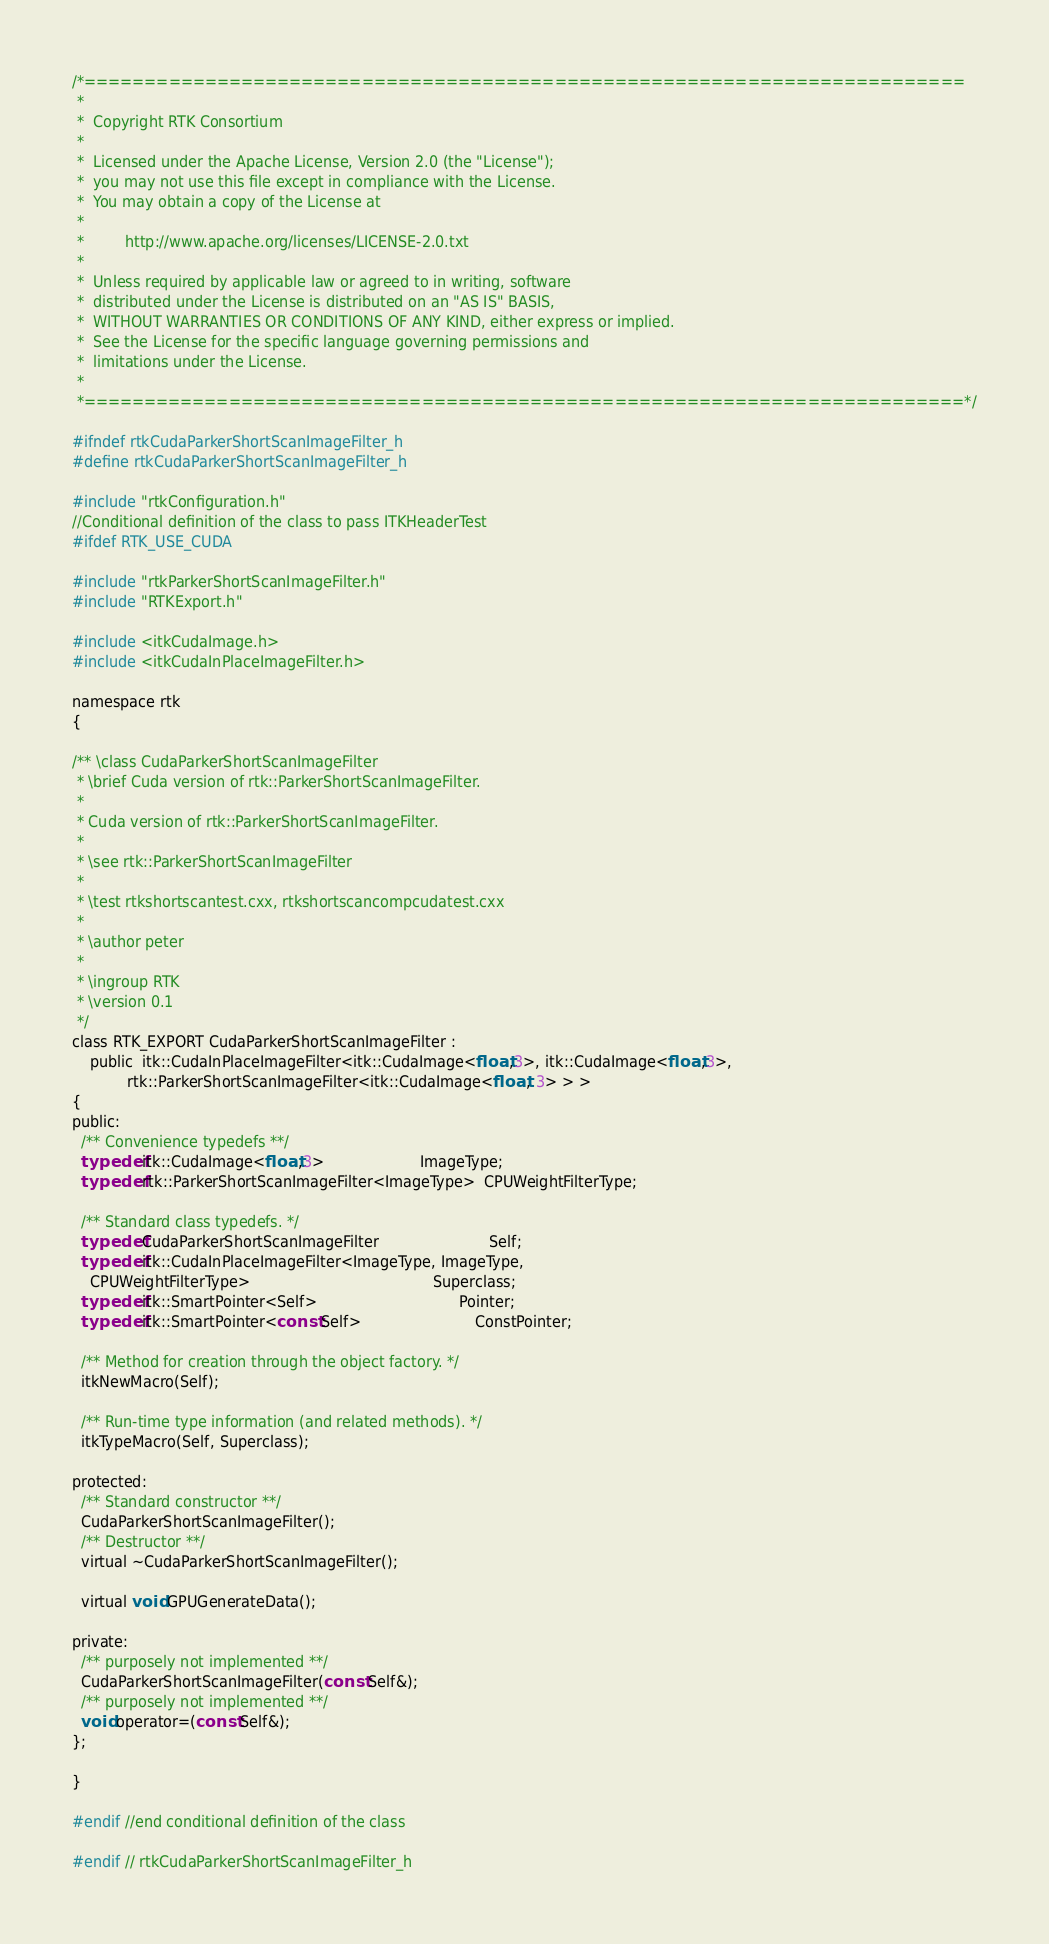Convert code to text. <code><loc_0><loc_0><loc_500><loc_500><_C_>/*=========================================================================
 *
 *  Copyright RTK Consortium
 *
 *  Licensed under the Apache License, Version 2.0 (the "License");
 *  you may not use this file except in compliance with the License.
 *  You may obtain a copy of the License at
 *
 *         http://www.apache.org/licenses/LICENSE-2.0.txt
 *
 *  Unless required by applicable law or agreed to in writing, software
 *  distributed under the License is distributed on an "AS IS" BASIS,
 *  WITHOUT WARRANTIES OR CONDITIONS OF ANY KIND, either express or implied.
 *  See the License for the specific language governing permissions and
 *  limitations under the License.
 *
 *=========================================================================*/

#ifndef rtkCudaParkerShortScanImageFilter_h
#define rtkCudaParkerShortScanImageFilter_h

#include "rtkConfiguration.h"
//Conditional definition of the class to pass ITKHeaderTest
#ifdef RTK_USE_CUDA

#include "rtkParkerShortScanImageFilter.h"
#include "RTKExport.h"

#include <itkCudaImage.h>
#include <itkCudaInPlaceImageFilter.h>

namespace rtk
{

/** \class CudaParkerShortScanImageFilter
 * \brief Cuda version of rtk::ParkerShortScanImageFilter.
 *
 * Cuda version of rtk::ParkerShortScanImageFilter.
 *
 * \see rtk::ParkerShortScanImageFilter
 *
 * \test rtkshortscantest.cxx, rtkshortscancompcudatest.cxx
 *
 * \author peter
 *
 * \ingroup RTK
 * \version 0.1
 */
class RTK_EXPORT CudaParkerShortScanImageFilter :
    public  itk::CudaInPlaceImageFilter<itk::CudaImage<float,3>, itk::CudaImage<float,3>,
            rtk::ParkerShortScanImageFilter<itk::CudaImage<float, 3> > >
{
public:
  /** Convenience typedefs **/
  typedef itk::CudaImage<float,3>                     ImageType;
  typedef rtk::ParkerShortScanImageFilter<ImageType>  CPUWeightFilterType;

  /** Standard class typedefs. */
  typedef CudaParkerShortScanImageFilter                        Self;
  typedef itk::CudaInPlaceImageFilter<ImageType, ImageType,
    CPUWeightFilterType>                                        Superclass;
  typedef itk::SmartPointer<Self>                               Pointer;
  typedef itk::SmartPointer<const Self>                         ConstPointer;

  /** Method for creation through the object factory. */
  itkNewMacro(Self);

  /** Run-time type information (and related methods). */
  itkTypeMacro(Self, Superclass);

protected:
  /** Standard constructor **/
  CudaParkerShortScanImageFilter();
  /** Destructor **/
  virtual ~CudaParkerShortScanImageFilter();

  virtual void GPUGenerateData();

private:
  /** purposely not implemented **/
  CudaParkerShortScanImageFilter(const Self&);
  /** purposely not implemented **/
  void operator=(const Self&);
};

}

#endif //end conditional definition of the class

#endif // rtkCudaParkerShortScanImageFilter_h
</code> 